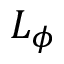Convert formula to latex. <formula><loc_0><loc_0><loc_500><loc_500>L _ { \phi }</formula> 